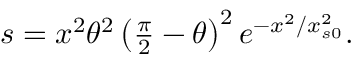<formula> <loc_0><loc_0><loc_500><loc_500>\begin{array} { r } { s = x ^ { 2 } \theta ^ { 2 } \left ( \frac { \pi } { 2 } - \theta \right ) ^ { 2 } e ^ { - x ^ { 2 } / x _ { s 0 } ^ { 2 } } . } \end{array}</formula> 